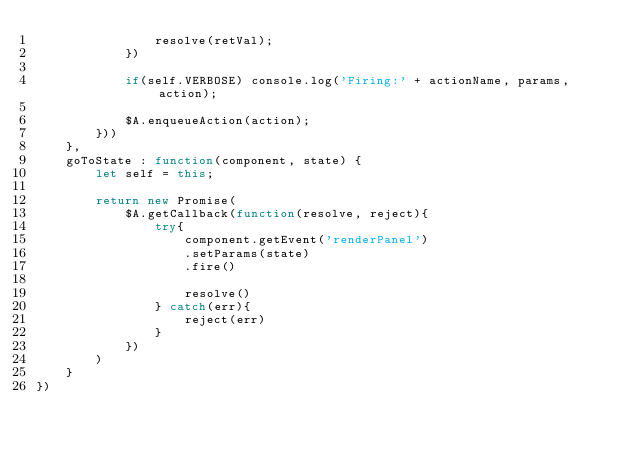<code> <loc_0><loc_0><loc_500><loc_500><_JavaScript_>                resolve(retVal);
            })
            
            if(self.VERBOSE) console.log('Firing:' + actionName, params, action);
            
            $A.enqueueAction(action);
        }))
    },
    goToState : function(component, state) {
        let self = this;
        
        return new Promise(
            $A.getCallback(function(resolve, reject){
                try{
                    component.getEvent('renderPanel')
                    .setParams(state)
                    .fire()
                    
                    resolve()
                } catch(err){
                    reject(err)
                }
            })
        )
    }
})</code> 